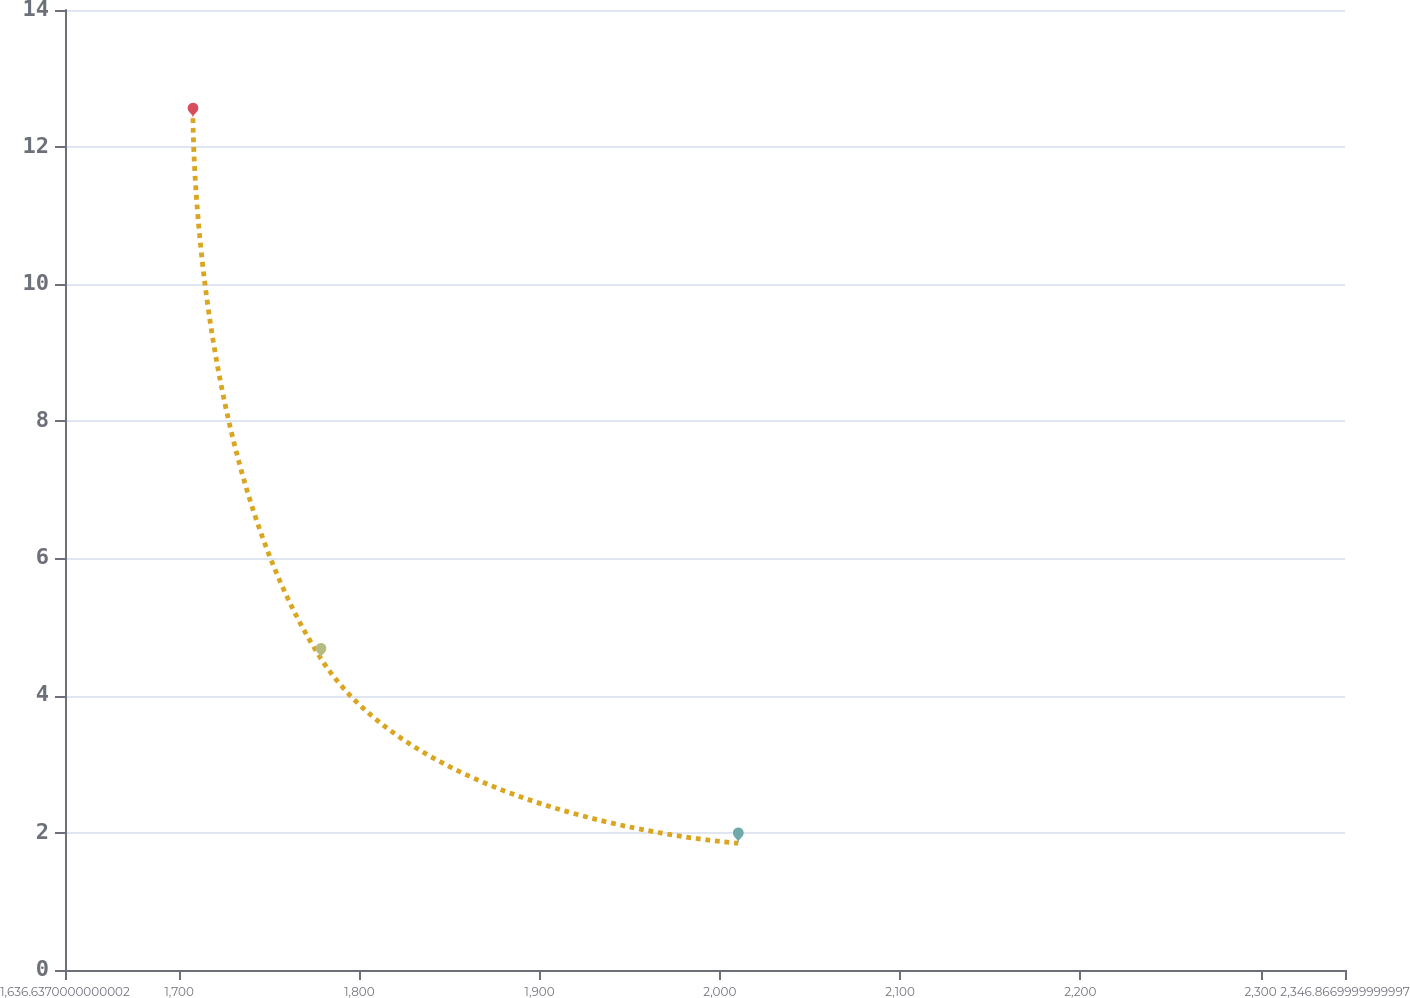Convert chart to OTSL. <chart><loc_0><loc_0><loc_500><loc_500><line_chart><ecel><fcel>Unnamed: 1<nl><fcel>1707.66<fcel>12.42<nl><fcel>1778.68<fcel>4.54<nl><fcel>2010.22<fcel>1.85<nl><fcel>2417.89<fcel>0.68<nl></chart> 